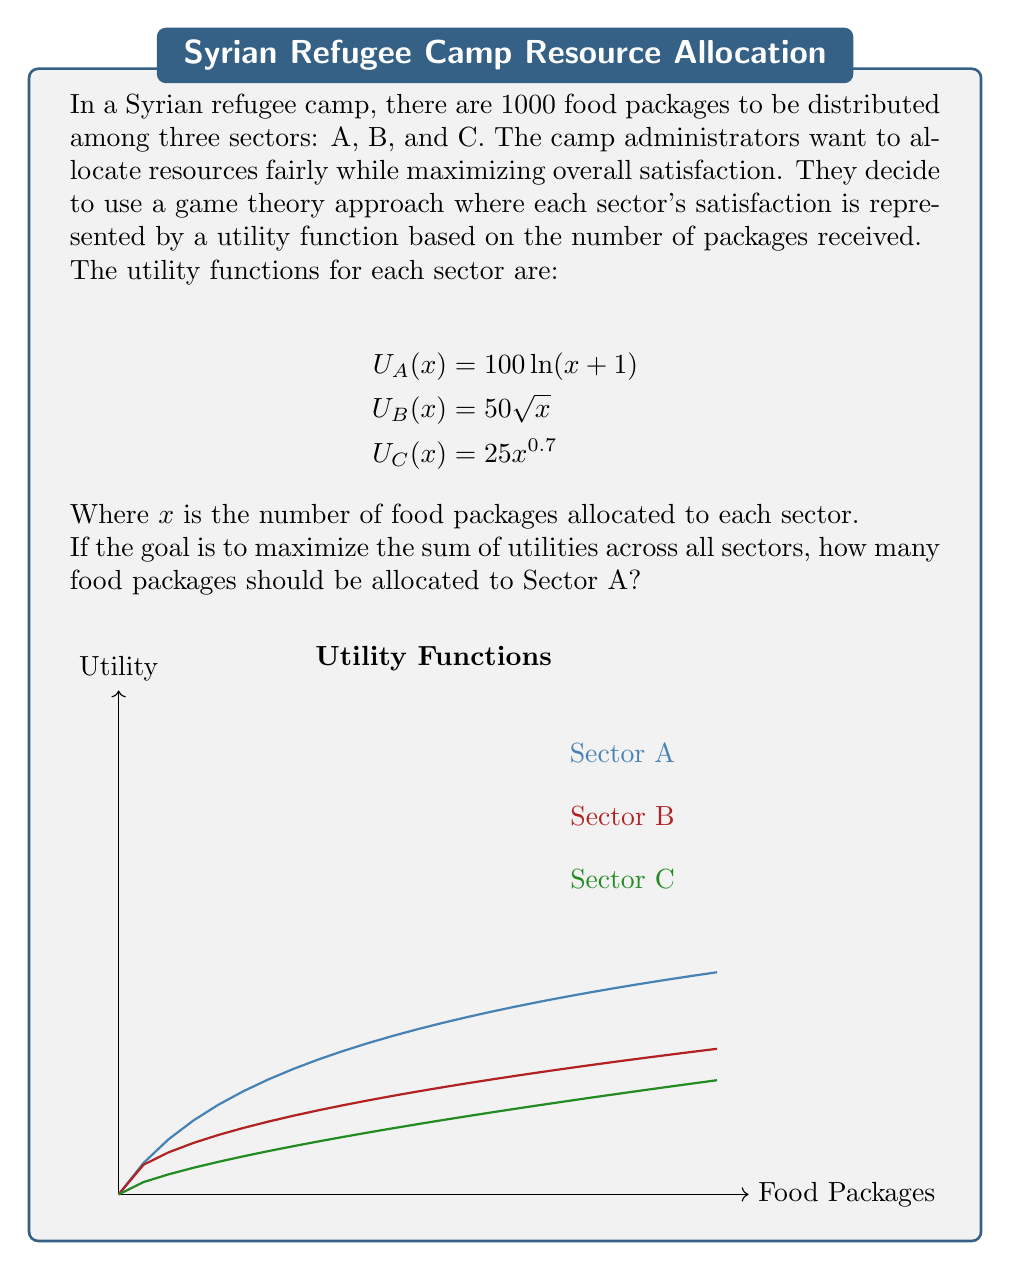Provide a solution to this math problem. To solve this problem, we need to use the principle of marginal utility in game theory. The optimal allocation occurs when the marginal utilities of all sectors are equal. Let's approach this step-by-step:

1) First, we need to find the marginal utility functions by differentiating each utility function:

   $$MU_A(x) = \frac{d}{dx}U_A(x) = \frac{100}{x+1}$$
   $$MU_B(x) = \frac{d}{dx}U_B(x) = \frac{25}{\sqrt{x}}$$
   $$MU_C(x) = \frac{d}{dx}U_C(x) = 17.5x^{-0.3}$$

2) At the optimal allocation, these marginal utilities should be equal:

   $$\frac{100}{x_A+1} = \frac{25}{\sqrt{x_B}} = 17.5x_C^{-0.3}$$

3) We also know that the total number of packages is 1000:

   $$x_A + x_B + x_C = 1000$$

4) From the equality of marginal utilities, we can express $x_B$ and $x_C$ in terms of $x_A$:

   $$x_B = (\frac{25(x_A+1)}{100})^2 = \frac{(x_A+1)^2}{16}$$
   $$x_C = (\frac{100}{17.5(x_A+1)})^{\frac{10}{3}} = (\frac{40}{7(x_A+1)})^{\frac{10}{3}}$$

5) Substituting these into the total packages equation:

   $$x_A + \frac{(x_A+1)^2}{16} + (\frac{40}{7(x_A+1)})^{\frac{10}{3}} = 1000$$

6) This equation can be solved numerically. Using a computer algebra system or numerical methods, we find:

   $$x_A \approx 368.6$$

7) Since we can only allocate whole numbers of packages, we round to the nearest integer:

   $$x_A = 369$$

Thus, Sector A should be allocated 369 food packages for optimal resource distribution.
Answer: 369 packages 